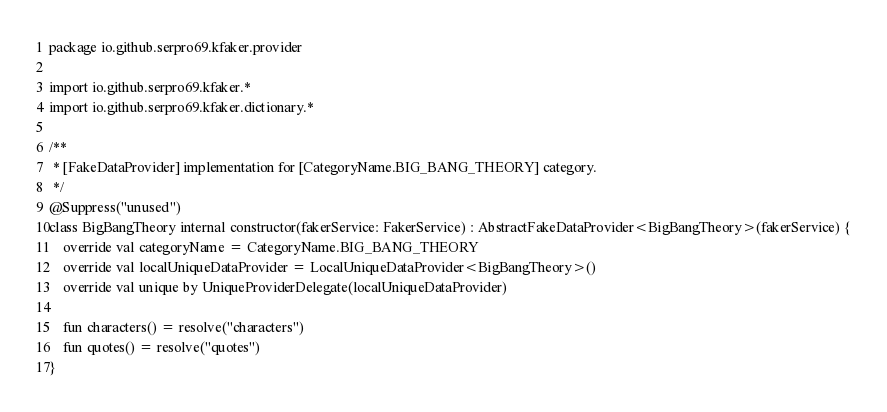<code> <loc_0><loc_0><loc_500><loc_500><_Kotlin_>package io.github.serpro69.kfaker.provider

import io.github.serpro69.kfaker.*
import io.github.serpro69.kfaker.dictionary.*

/**
 * [FakeDataProvider] implementation for [CategoryName.BIG_BANG_THEORY] category.
 */
@Suppress("unused")
class BigBangTheory internal constructor(fakerService: FakerService) : AbstractFakeDataProvider<BigBangTheory>(fakerService) {
    override val categoryName = CategoryName.BIG_BANG_THEORY
    override val localUniqueDataProvider = LocalUniqueDataProvider<BigBangTheory>()
    override val unique by UniqueProviderDelegate(localUniqueDataProvider)

    fun characters() = resolve("characters")
    fun quotes() = resolve("quotes")
}</code> 